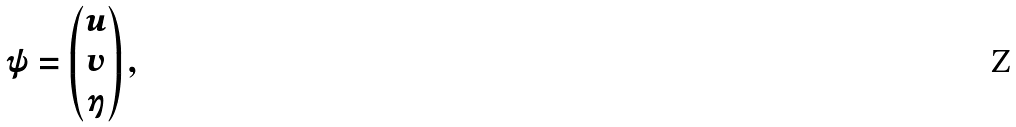<formula> <loc_0><loc_0><loc_500><loc_500>\psi = \begin{pmatrix} u \\ v \\ \eta \end{pmatrix} ,</formula> 